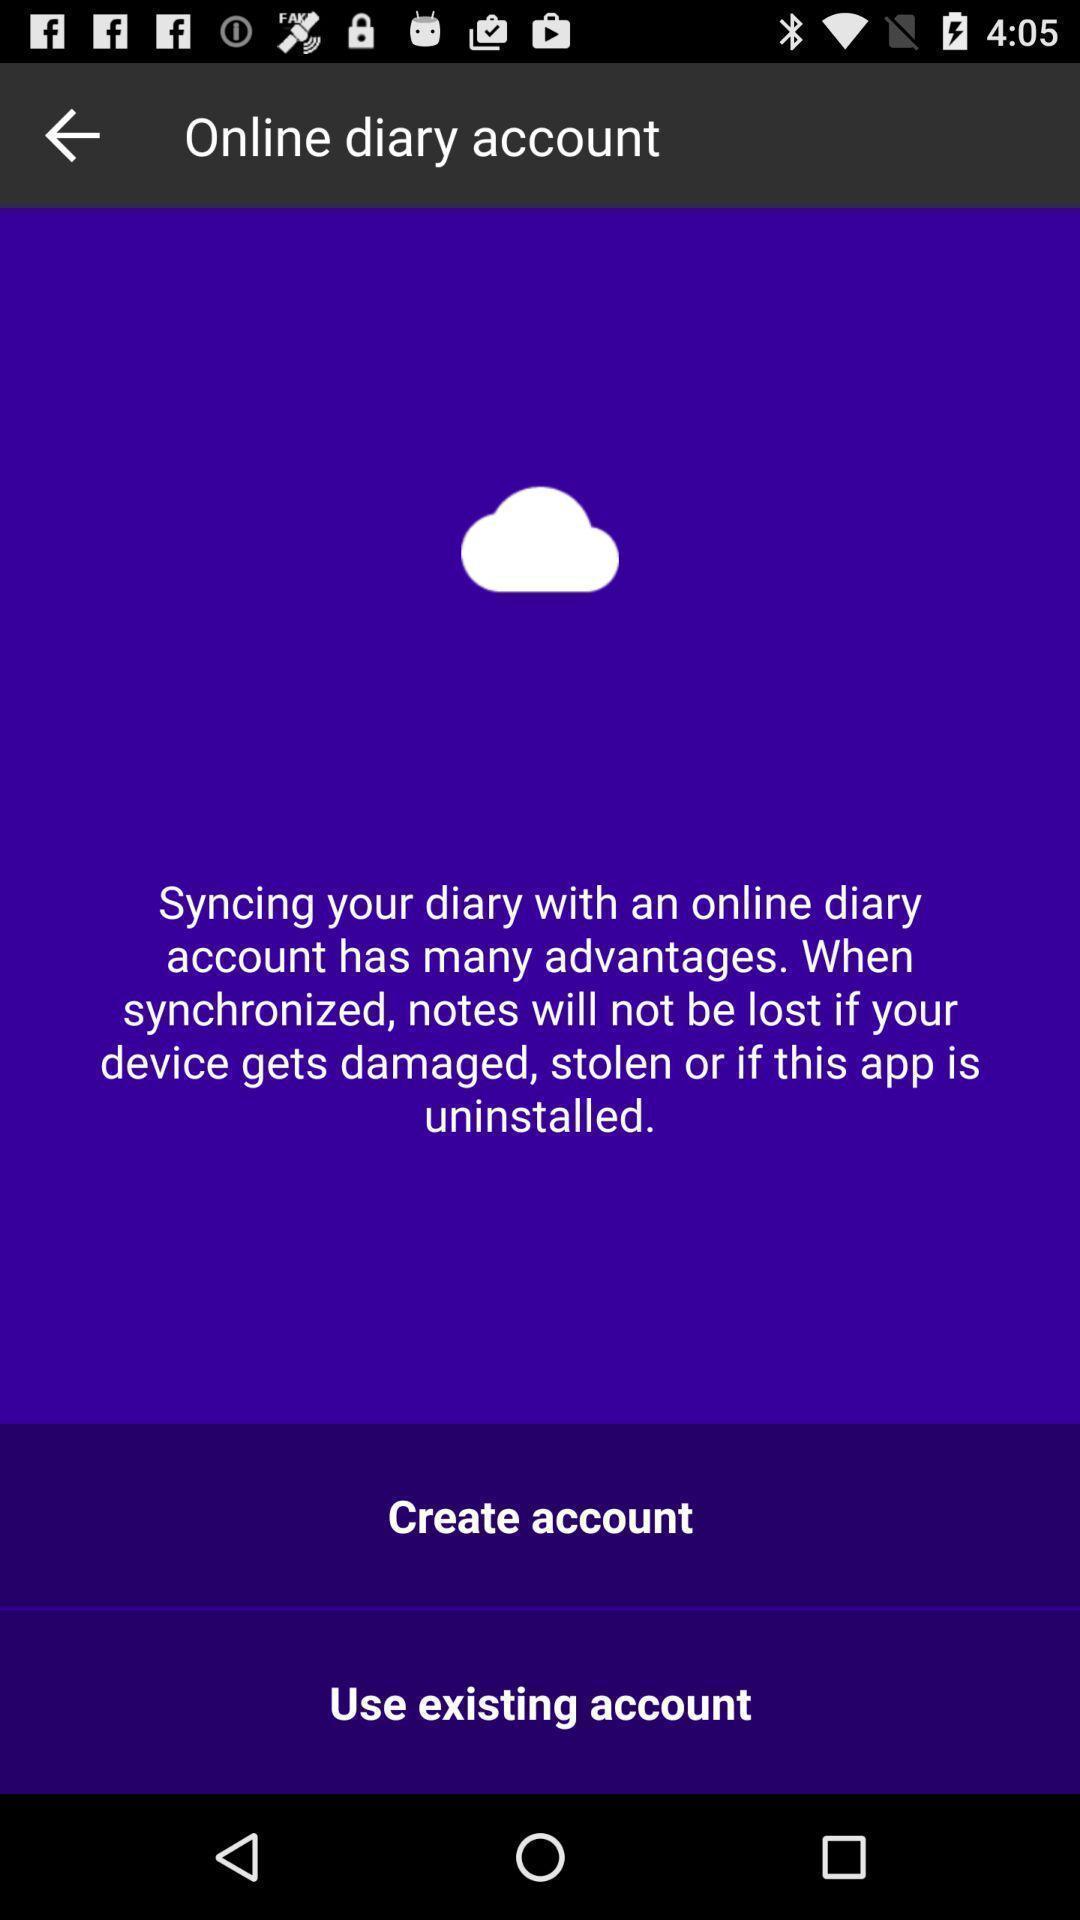Provide a description of this screenshot. Welcome page of notes application. 